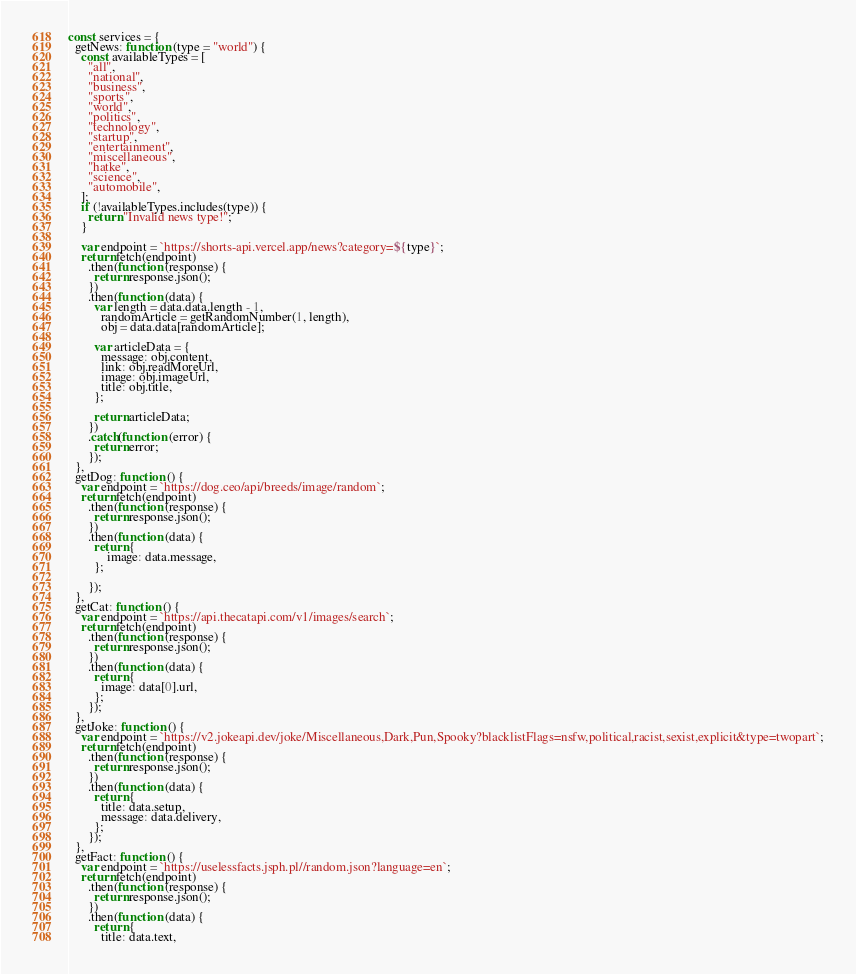Convert code to text. <code><loc_0><loc_0><loc_500><loc_500><_JavaScript_>const services = {
  getNews: function (type = "world") {
    const availableTypes = [
      "all",
      "national",
      "business",
      "sports",
      "world",
      "politics",
      "technology",
      "startup",
      "entertainment",
      "miscellaneous",
      "hatke",
      "science",
      "automobile",
    ];
    if (!availableTypes.includes(type)) {
      return "Invalid news type!";
    }

    var endpoint = `https://shorts-api.vercel.app/news?category=${type}`;
    return fetch(endpoint)
      .then(function (response) {
        return response.json();
      })
      .then(function (data) {
        var length = data.data.length - 1,
          randomArticle = getRandomNumber(1, length),
          obj = data.data[randomArticle];

        var articleData = {
          message: obj.content,
          link: obj.readMoreUrl,
          image: obj.imageUrl,
          title: obj.title,
        };

        return articleData;
      })
      .catch(function (error) {
        return error;
      });
  },
  getDog: function () {
    var endpoint = `https://dog.ceo/api/breeds/image/random`;
    return fetch(endpoint)
      .then(function (response) {
        return response.json();
      })
      .then(function (data) {
        return { 
            image: data.message, 
        };

      });
  },
  getCat: function () {
    var endpoint = `https://api.thecatapi.com/v1/images/search`;
    return fetch(endpoint)
      .then(function (response) {
        return response.json();
      })
      .then(function (data) {
        return {
          image: data[0].url,
        };
      });
  },
  getJoke: function () {
    var endpoint = `https://v2.jokeapi.dev/joke/Miscellaneous,Dark,Pun,Spooky?blacklistFlags=nsfw,political,racist,sexist,explicit&type=twopart`;
    return fetch(endpoint)
      .then(function (response) {
        return response.json();
      })
      .then(function (data) {
        return {
          title: data.setup,
          message: data.delivery,
        };
      });
  },
  getFact: function () {
    var endpoint = `https://uselessfacts.jsph.pl//random.json?language=en`;
    return fetch(endpoint)
      .then(function (response) {
        return response.json();
      })
      .then(function (data) {
        return {
          title: data.text,</code> 